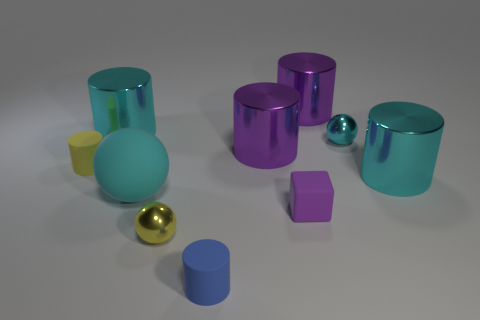Subtract all yellow cylinders. How many cylinders are left? 5 Subtract all purple metallic cylinders. How many cylinders are left? 4 Subtract all cyan cylinders. Subtract all blue balls. How many cylinders are left? 4 Subtract all cylinders. How many objects are left? 4 Subtract all yellow matte cylinders. Subtract all big balls. How many objects are left? 8 Add 6 large cyan spheres. How many large cyan spheres are left? 7 Add 3 tiny purple shiny objects. How many tiny purple shiny objects exist? 3 Subtract 0 purple spheres. How many objects are left? 10 